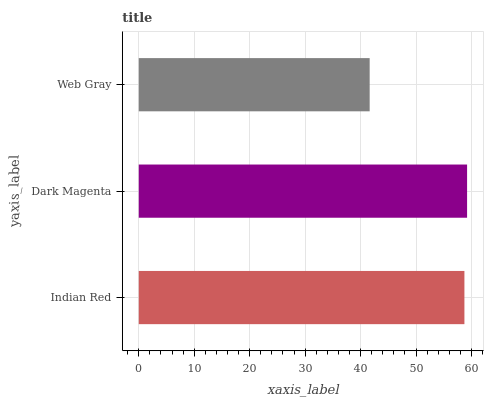Is Web Gray the minimum?
Answer yes or no. Yes. Is Dark Magenta the maximum?
Answer yes or no. Yes. Is Dark Magenta the minimum?
Answer yes or no. No. Is Web Gray the maximum?
Answer yes or no. No. Is Dark Magenta greater than Web Gray?
Answer yes or no. Yes. Is Web Gray less than Dark Magenta?
Answer yes or no. Yes. Is Web Gray greater than Dark Magenta?
Answer yes or no. No. Is Dark Magenta less than Web Gray?
Answer yes or no. No. Is Indian Red the high median?
Answer yes or no. Yes. Is Indian Red the low median?
Answer yes or no. Yes. Is Dark Magenta the high median?
Answer yes or no. No. Is Dark Magenta the low median?
Answer yes or no. No. 